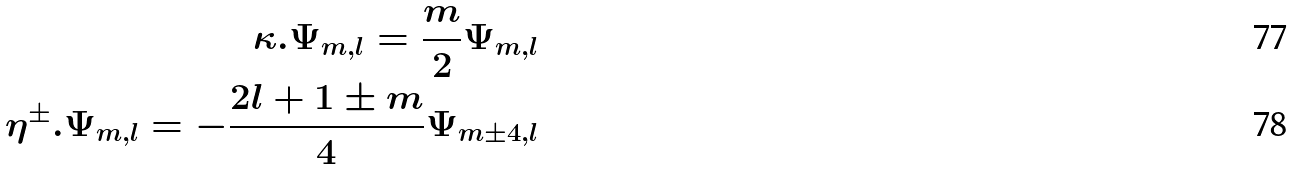<formula> <loc_0><loc_0><loc_500><loc_500>\kappa . \Psi _ { m , l } = \frac { m } { 2 } \Psi _ { m , l } \\ \eta ^ { \pm } . \Psi _ { m , l } = - \frac { 2 l + 1 \pm m } { 4 } \Psi _ { m \pm 4 , l }</formula> 